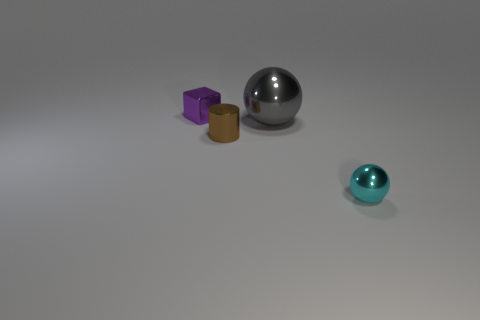Do the purple cube and the cyan shiny sphere have the same size?
Your response must be concise. Yes. Are the ball that is behind the cyan thing and the small object to the right of the metal cylinder made of the same material?
Offer a very short reply. Yes. The tiny object that is behind the shiny ball that is to the left of the small shiny object that is in front of the brown metallic cylinder is what shape?
Your answer should be very brief. Cube. Are there more brown shiny cylinders than large purple metallic cylinders?
Keep it short and to the point. Yes. Is there a gray ball?
Provide a short and direct response. Yes. What number of things are either tiny things behind the gray shiny object or small shiny things that are behind the cyan thing?
Offer a terse response. 2. Is the number of small cyan shiny spheres less than the number of big purple matte cylinders?
Give a very brief answer. No. Are there any small cyan balls on the right side of the cyan sphere?
Your answer should be very brief. No. Are the small purple block and the tiny brown thing made of the same material?
Offer a very short reply. Yes. What color is the other shiny object that is the same shape as the cyan thing?
Offer a terse response. Gray. 